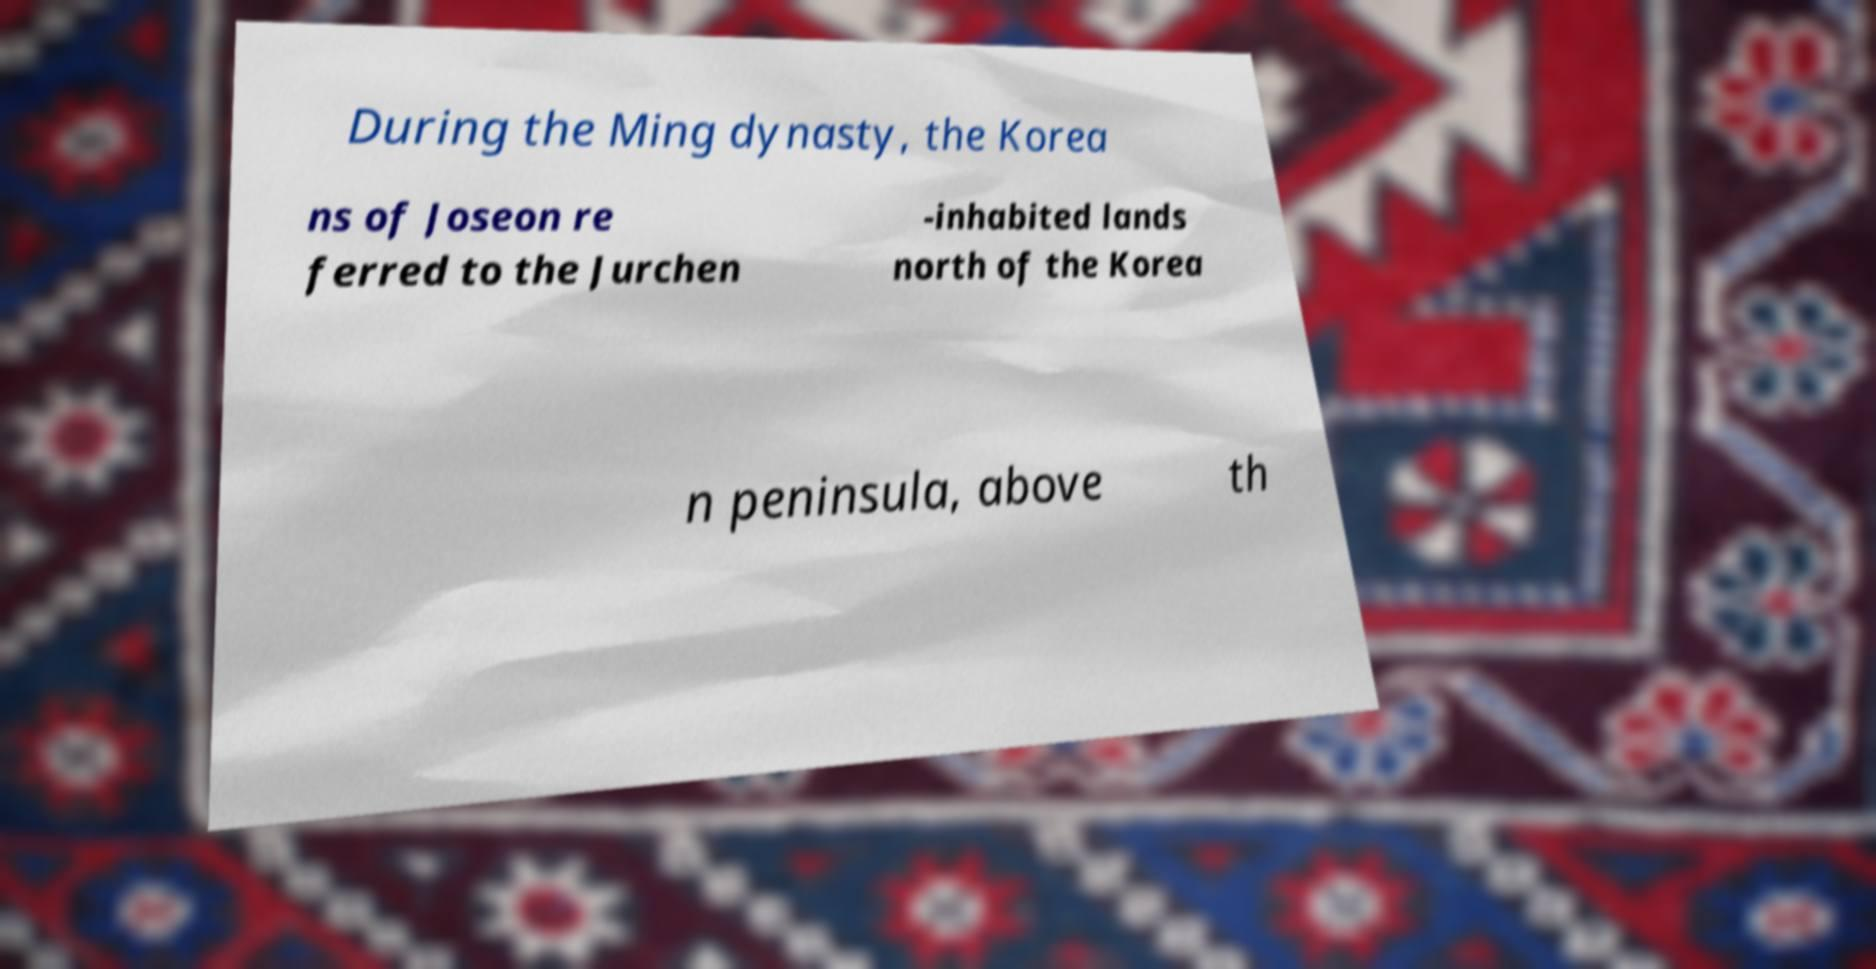Please identify and transcribe the text found in this image. During the Ming dynasty, the Korea ns of Joseon re ferred to the Jurchen -inhabited lands north of the Korea n peninsula, above th 